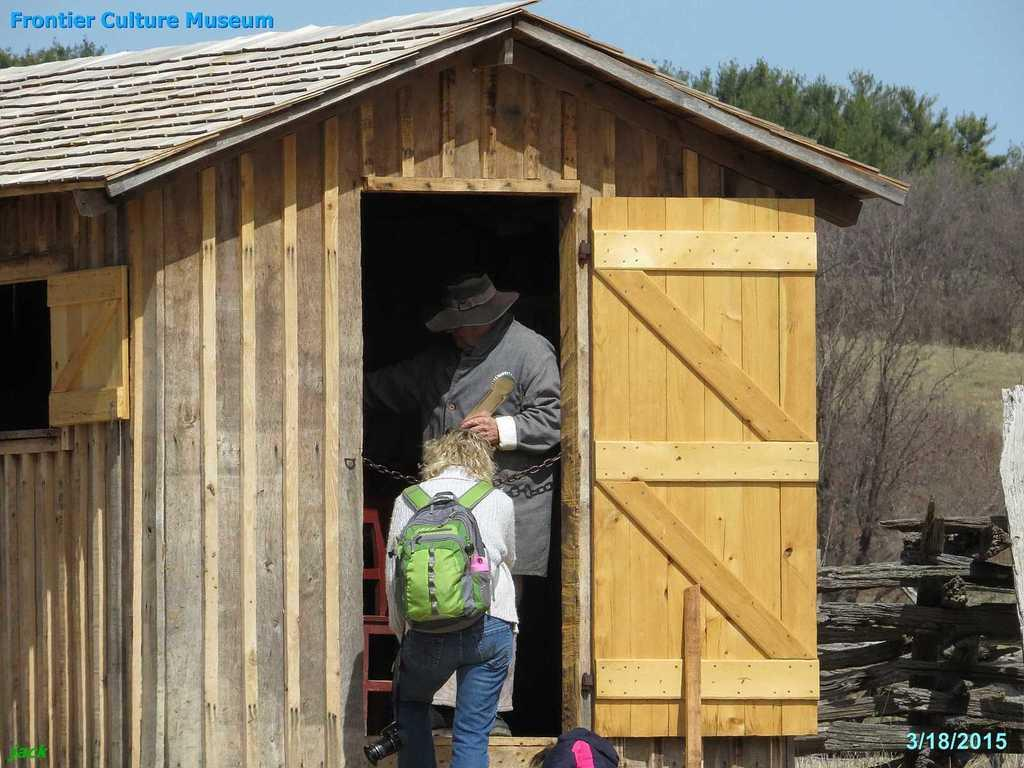What can be seen in the background of the image? There is a sky in the image. What type of vegetation is present in the image? There are trees in the image. What type of structure is visible in the image? There is a wooden house in the image. How many people are present in the image? There are two people in the image. What type of belief is depicted in the image? There is no depiction of a belief in the image; it features a sky, trees, a wooden house, and two people. Can you tell me how many dolls are present in the image? There are no dolls present in the image. 